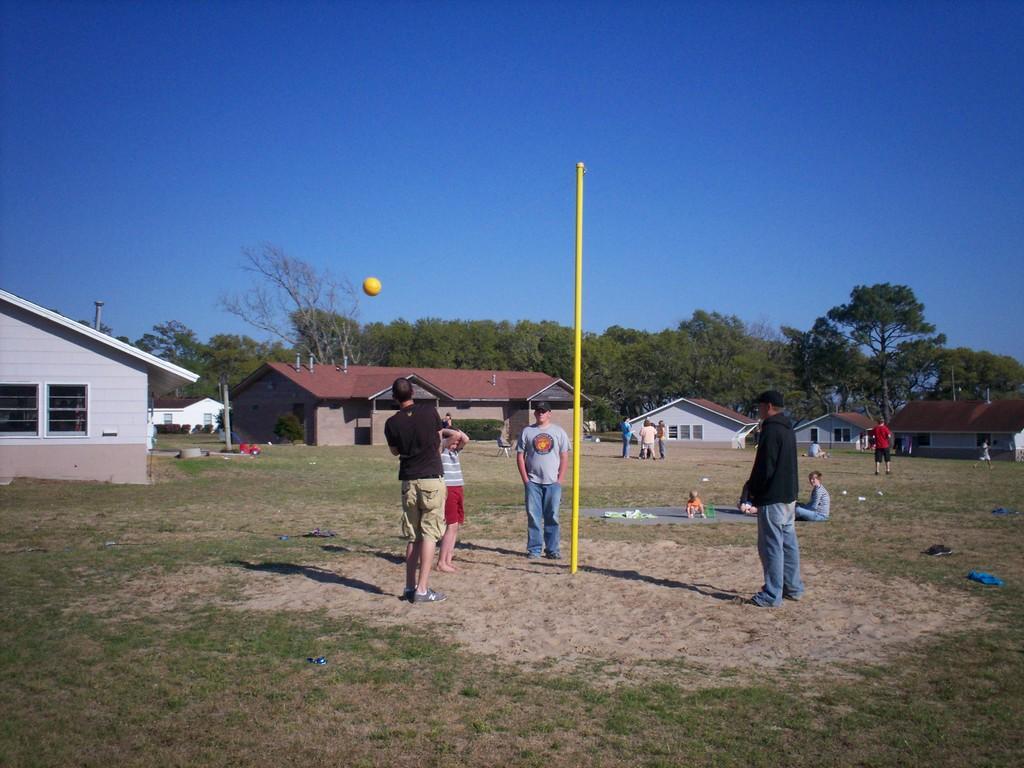Can you describe this image briefly? As we can see in the image there are few people here and there, grass, houses, yellow color ball, trees and sky. 